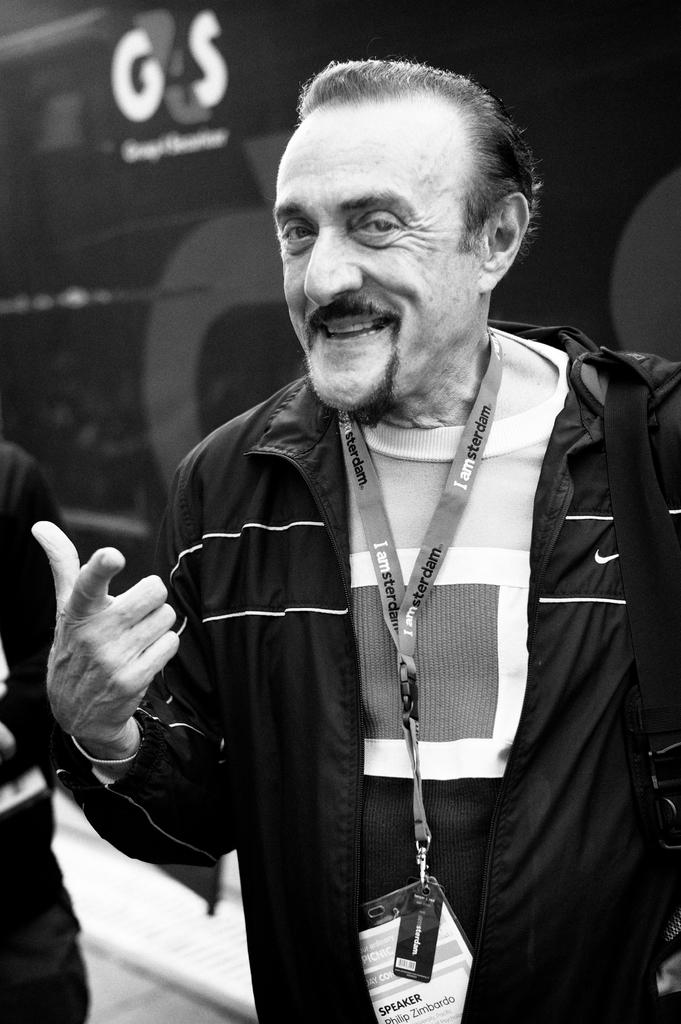How many people are present in the image? There are two persons in the image. What can be seen in the background of the image? There is a wall with text in the background of the image. What type of rings can be seen on the committee members in the image? There is no committee or rings present in the image; it features two persons and a wall with text in the background. 